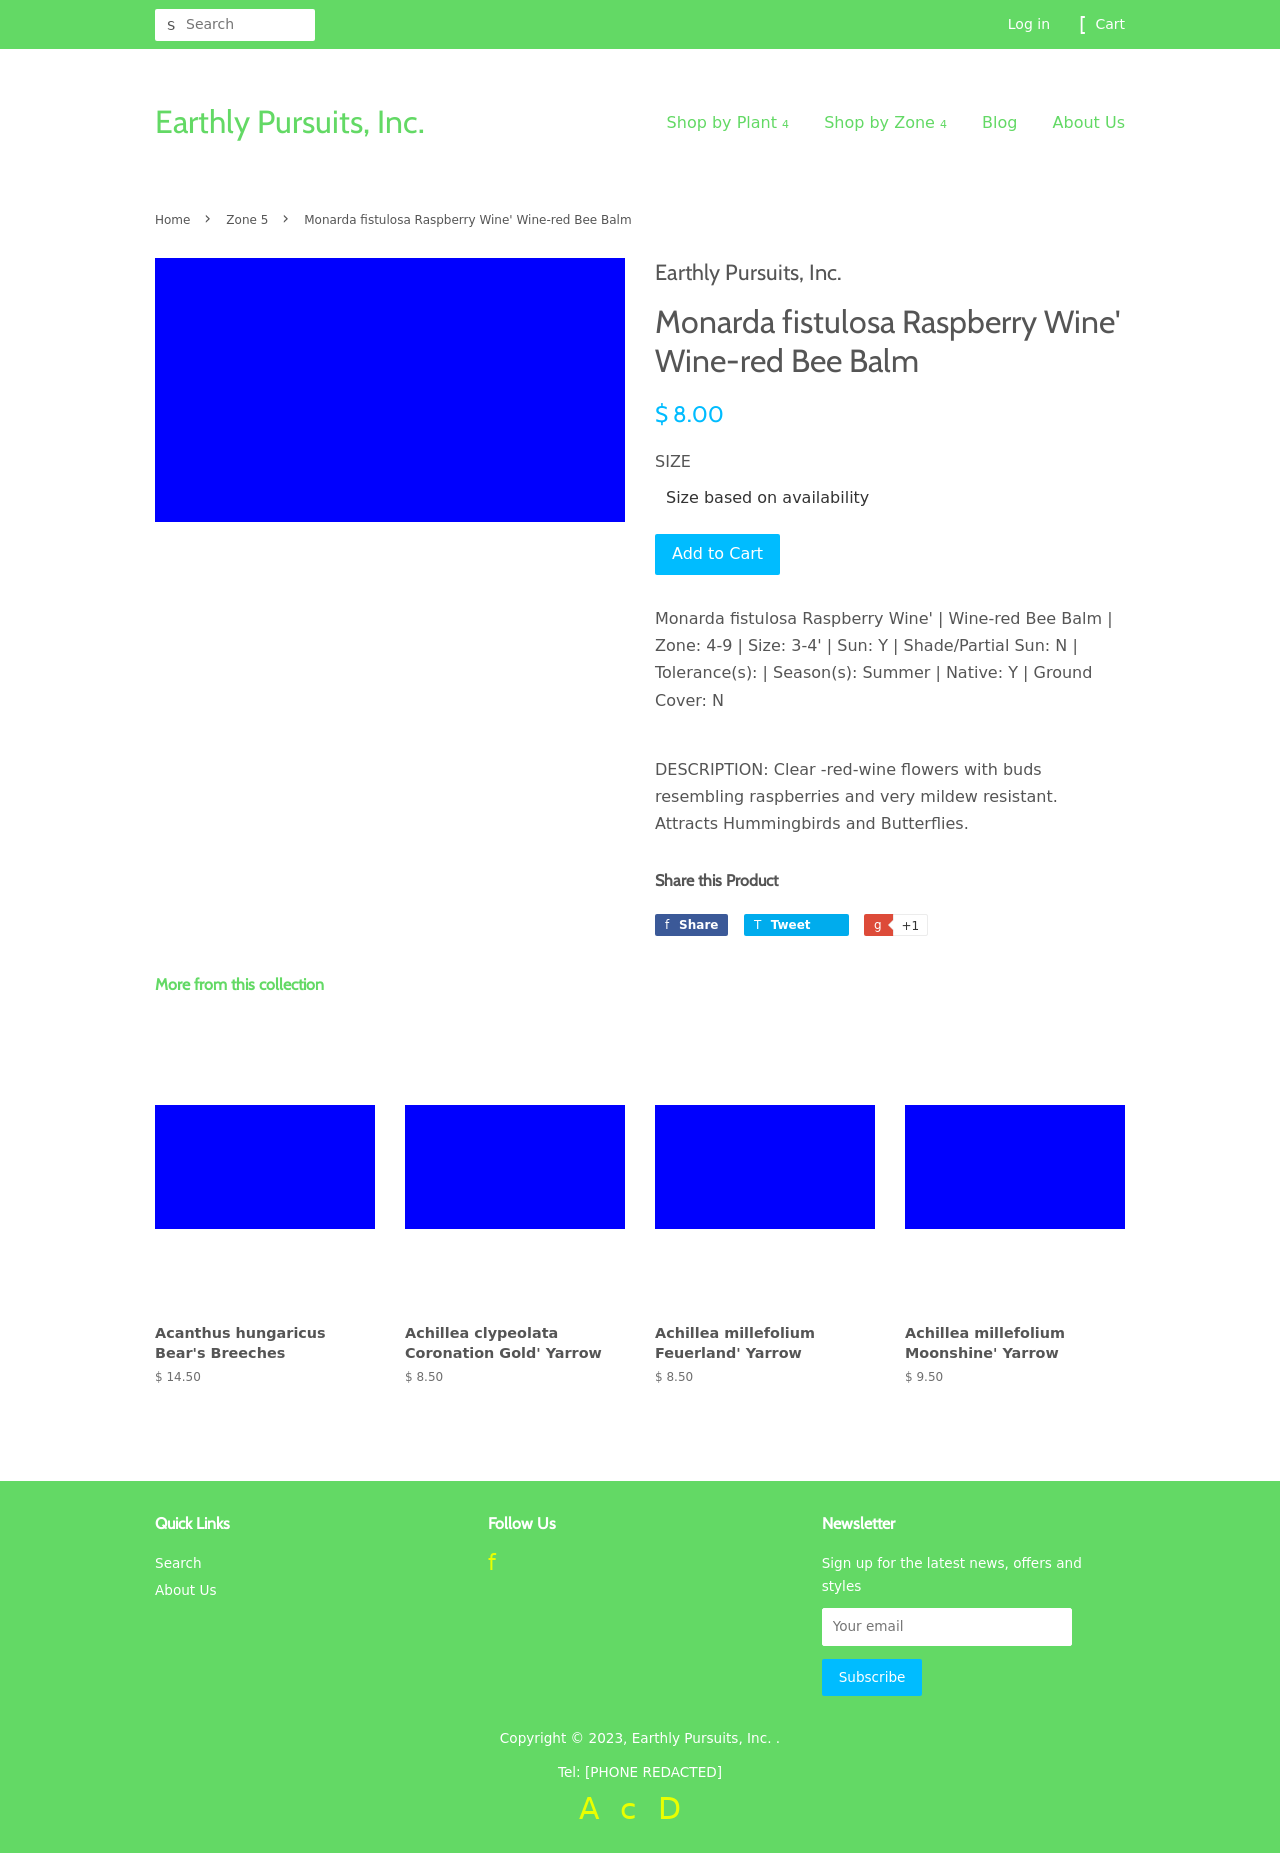How is the visual hierarchy structured on this page to guide the viewer's attention? The visual hierarchy on the page is designed to draw attention firstly to the plant's name and price with prominent positioning and bold typography. Following this, user focus is directed to the purchase option with an explicit 'Add to Cart' button and size options, which is critical for conversion. Descriptive text about the plant and further links for social sharing are subtly positioned to provide more in-depth information without overwhelming the primary purchase action. The navigation bar at the top and the collection at the bottom support further exploration without detracting from the main product focus. 